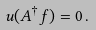<formula> <loc_0><loc_0><loc_500><loc_500>u ( A ^ { \dagger } f ) = 0 \, .</formula> 